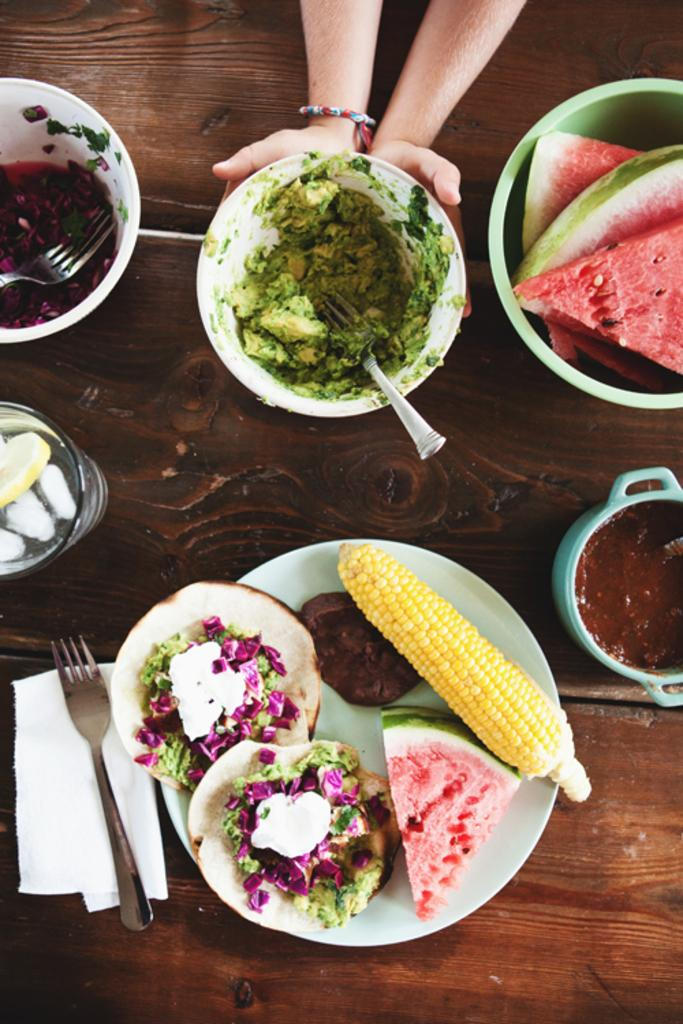What type of dishware is present in the image? There are bowls and a plate in the image. What utensils are visible in the image? There are forks in the image. What is being served on the dishware? There are food items in the image. Where are the bowls, plate, forks, and food items located? They are on a platform in the image. Can you describe any other elements in the image? There are also a person's hands visible in the background of the image. What type of key is being used to unlock the road in the image? There is no key or road present in the image; it features related to dishware, utensils, and food items are visible. 